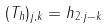Convert formula to latex. <formula><loc_0><loc_0><loc_500><loc_500>( T _ { h } ) _ { j , k } = h _ { 2 \cdot j - k }</formula> 